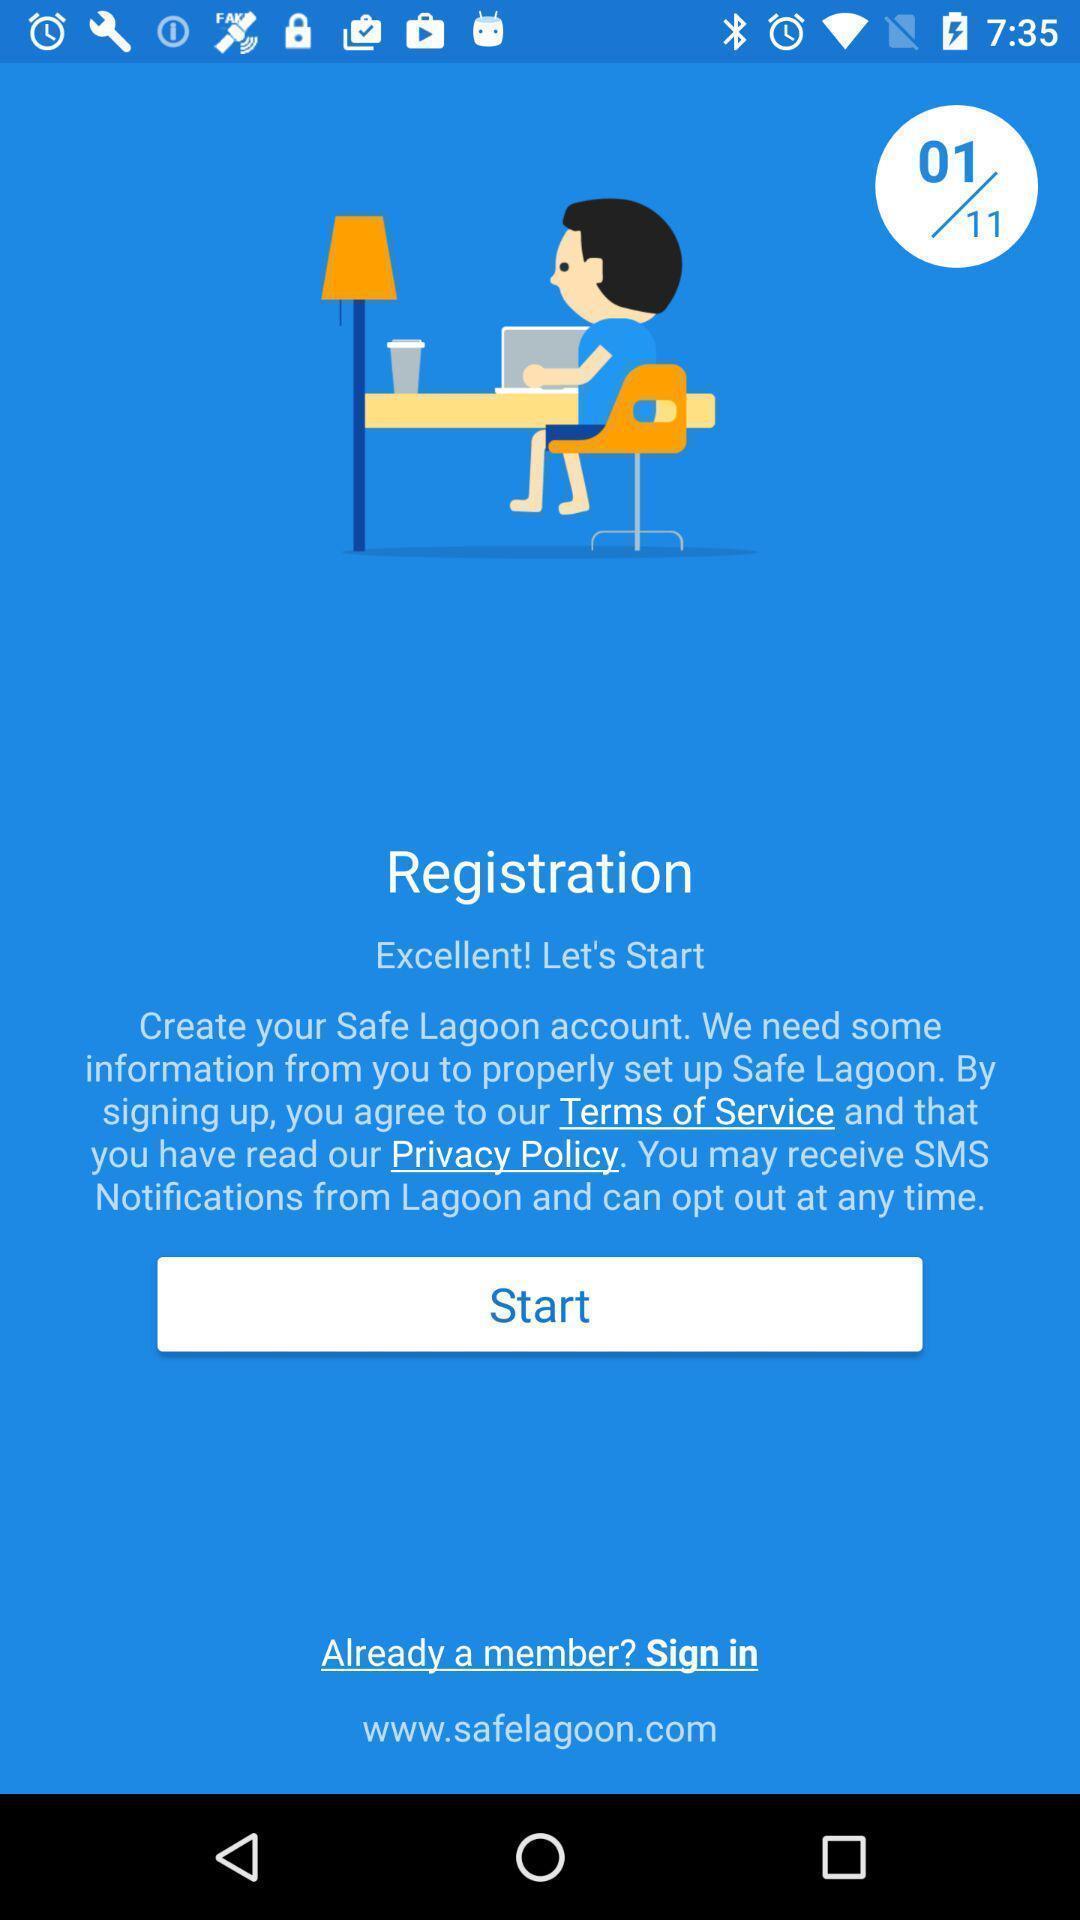Summarize the information in this screenshot. Welcome page asking for registration in a social app. 